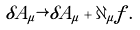Convert formula to latex. <formula><loc_0><loc_0><loc_500><loc_500>\delta A _ { \mu } \rightarrow \delta A _ { \mu } + \partial _ { \mu } f \, .</formula> 